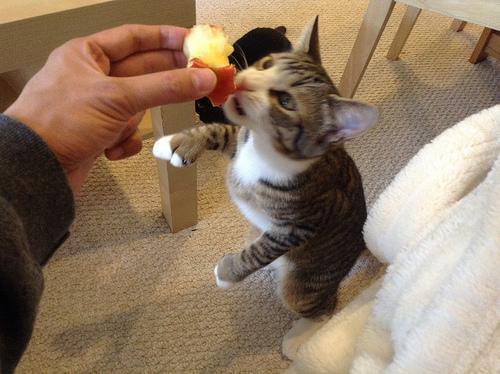How many cats are there?
Give a very brief answer. 1. 